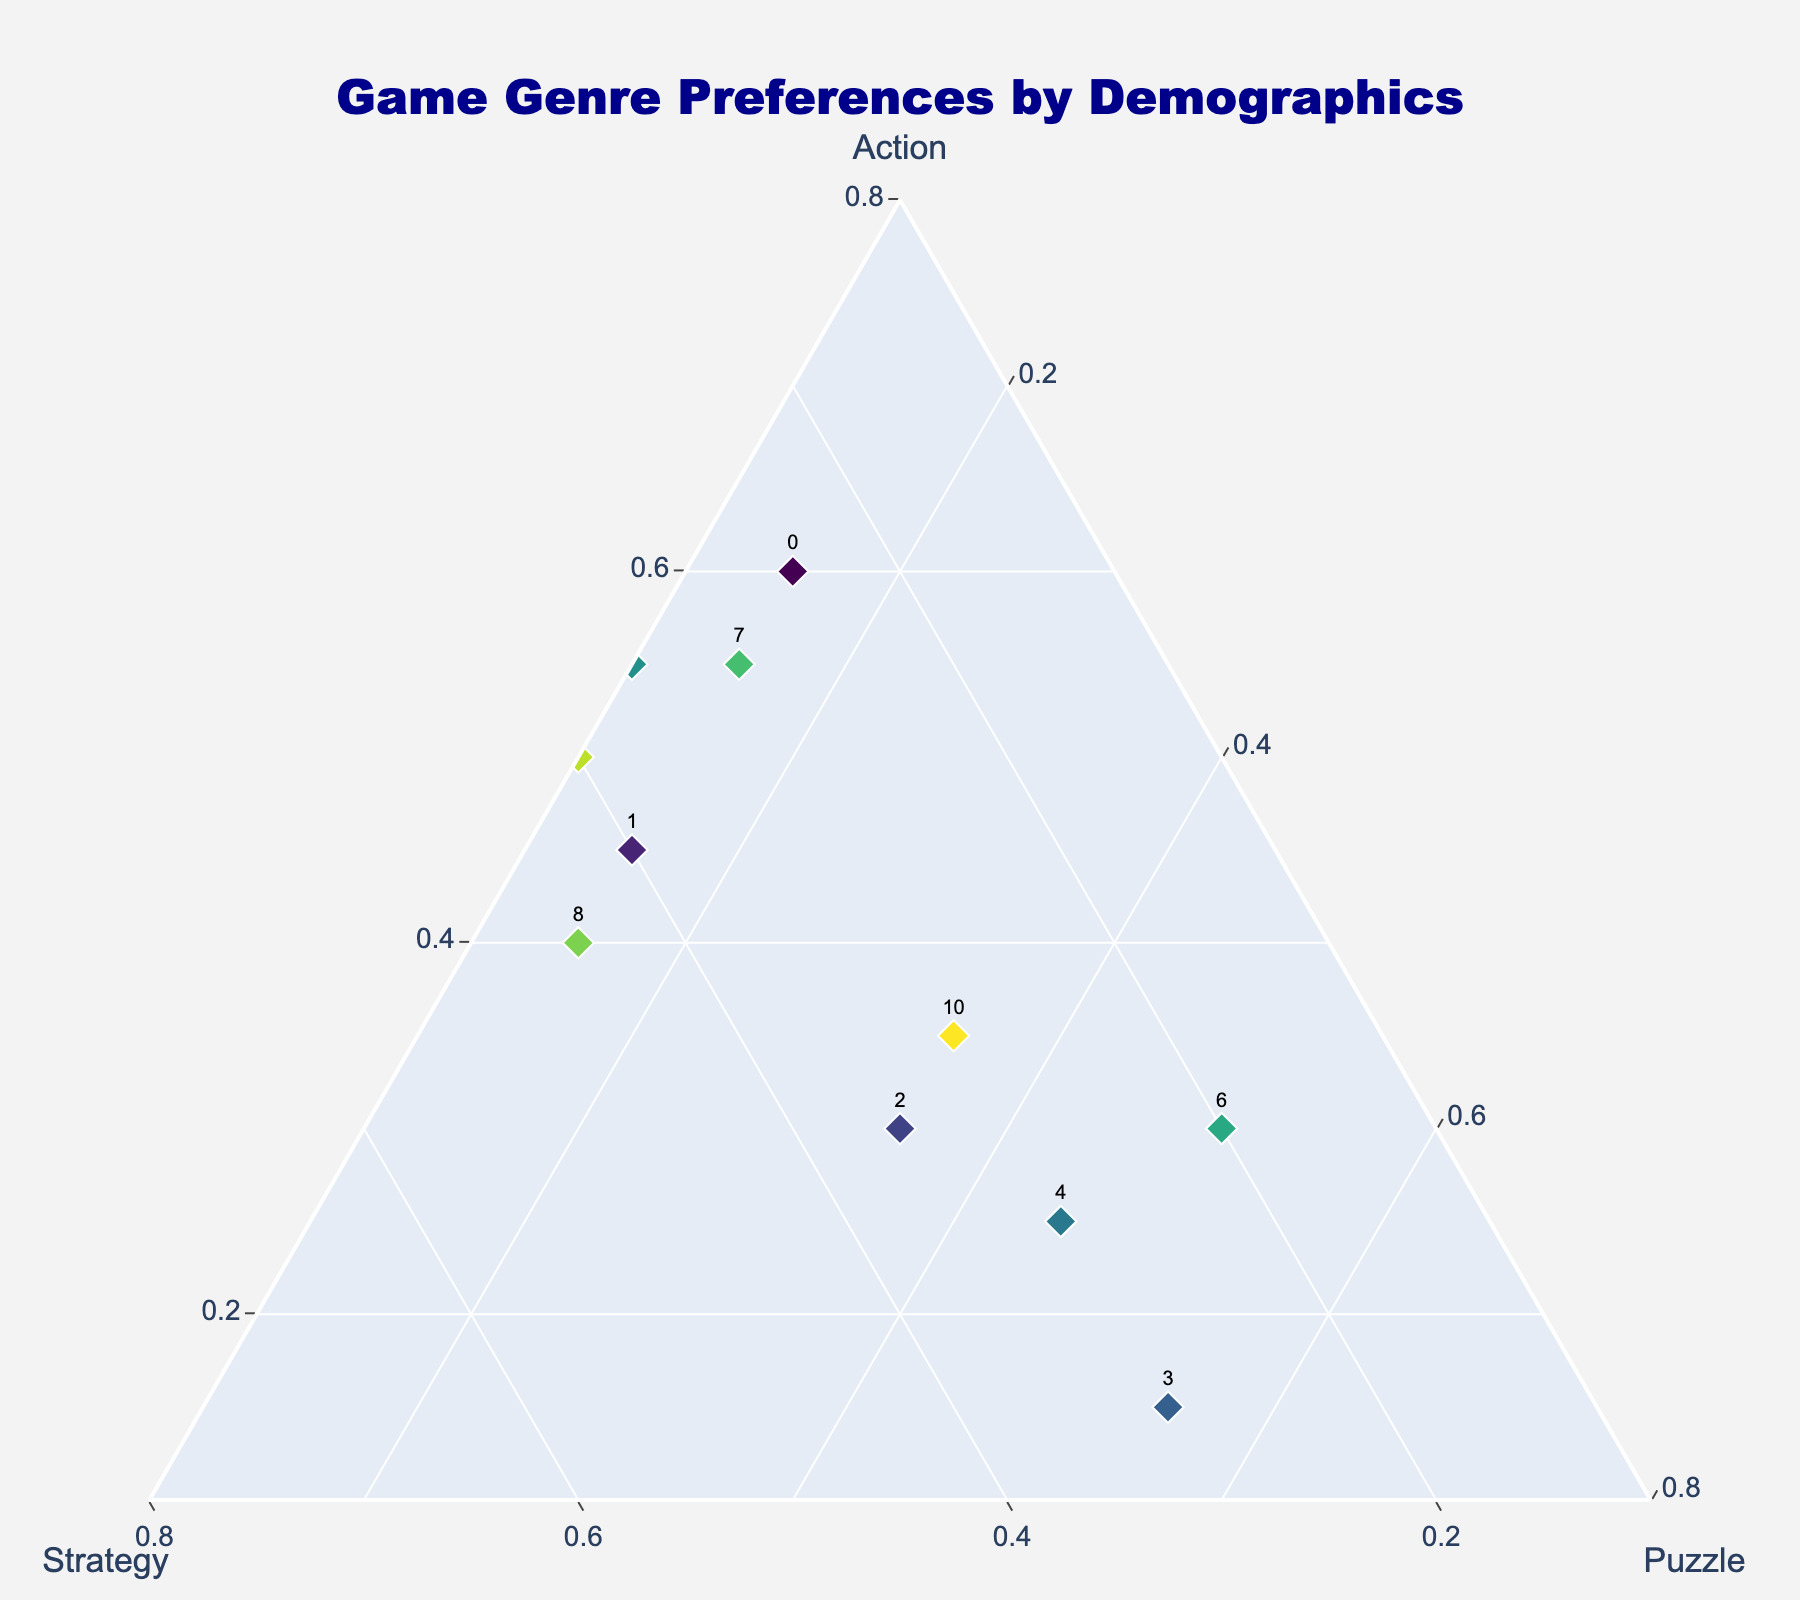What's the title of the plot? The title is given at the top center of the plot. Look at the central top area, you will see "Game Genre Preferences by Demographics" visible.
Answer: Game Genre Preferences by Demographics Which age group has the highest preference for Action games? Look at the vertex representing Action. Follow the line from Teens to that vertex and compare it with other lines extending from other age groups. Teens have the longest line, indicating the highest preference for Action games.
Answer: Teens Between Casual Gamers and Hardcore Gamers, who shows a greater preference for Puzzle games? Identify both groups on the plot and examine their positions relative to the Puzzle vertex. Casual Gamers are closer to the Puzzle vertex compared to Hardcore Gamers indicating a greater preference for Puzzle games.
Answer: Casual Gamers Which group has balanced preferences across Action, Strategy, and Puzzle games? Check for the point located near the center of the ternary plot because a balanced preference means almost equal distances from all three vertices (Action, Strategy, and Puzzle). Middle_Aged group is situated closest to the center indicating balanced preferences.
Answer: Middle_Aged What is the primary preference of Seniors from the plot? Locate the Seniors point and see which vertex it is closest to, indicating the primary genre. Seniors are closest to the Puzzle vertex, signifying their primary preference for Puzzle games.
Answer: Puzzle Which two groups have an equal preference for Strategy games? Identify groups that lie on the same line extending from the Strategy vertex. Young_Adults and Hardcore_Gamers are on the same line indicating they have an equal preference for Strategy games.
Answer: Young_Adults and Hardcore_Gamers What is the combined percentage preference for Puzzle games in the Casual Gamers and Seniors group? Read the percentage for Puzzle games from both groups and add them together from the plot. Casual Gamers have 0.45 and Seniors have 0.55. Adding them gives 0.45 + 0.55 = 1.00 (or 100%).
Answer: 1.00 (or 100%) Do Multiplayer Fans show a higher or lower preference for Action games compared to Single Player Enthusiasts? Compare their positions relative to the Action vertex. Multiplayer Fans are closer to the Action vertex, indicating a higher preference for Action games than Single Player Enthusiasts.
Answer: Higher 